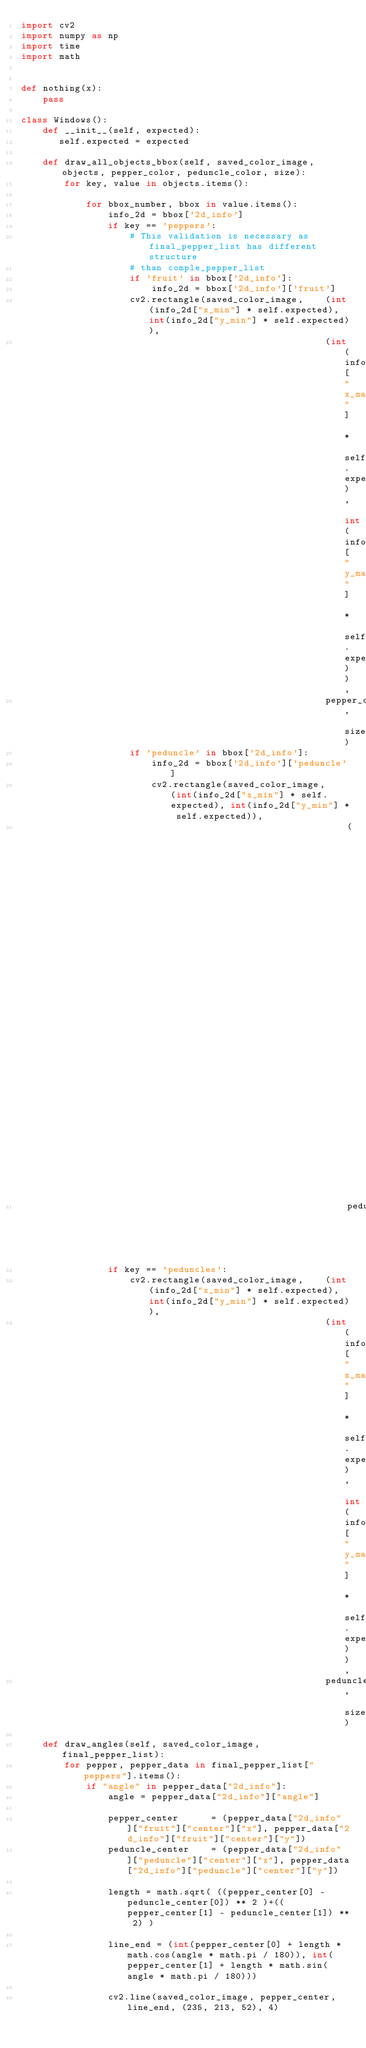<code> <loc_0><loc_0><loc_500><loc_500><_Python_>import cv2
import numpy as np
import time
import math


def nothing(x):
    pass

class Windows():
    def __init__(self, expected):
       self.expected = expected

    def draw_all_objects_bbox(self, saved_color_image, objects, pepper_color, peduncle_color, size):
        for key, value in objects.items():
            
            for bbox_number, bbox in value.items():
                info_2d = bbox['2d_info']
                if key == 'peppers':
                    # This validation is necessary as final_pepper_list has different structure
                    # than comple_pepper_list
                    if 'fruit' in bbox['2d_info']:
                        info_2d = bbox['2d_info']['fruit']
                    cv2.rectangle(saved_color_image,    (int(info_2d["x_min"] * self.expected), int(info_2d["y_min"] * self.expected)), 
                                                        (int(info_2d["x_max"] * self.expected), int(info_2d["y_max"] * self.expected)), 
                                                        pepper_color, size)
                    if 'peduncle' in bbox['2d_info']:
                        info_2d = bbox['2d_info']['peduncle']
                        cv2.rectangle(saved_color_image,    (int(info_2d["x_min"] * self.expected), int(info_2d["y_min"] * self.expected)), 
                                                            (int(info_2d["x_max"] * self.expected), int(info_2d["y_max"] * self.expected)), 
                                                            peduncle_color, size)
                if key == 'peduncles':
                    cv2.rectangle(saved_color_image,    (int(info_2d["x_min"] * self.expected), int(info_2d["y_min"] * self.expected)), 
                                                        (int(info_2d["x_max"] * self.expected), int(info_2d["y_max"] * self.expected)), 
                                                        peduncle_color, size)

    def draw_angles(self, saved_color_image, final_pepper_list):
        for pepper, pepper_data in final_pepper_list["peppers"].items():
            if "angle" in pepper_data["2d_info"]:
                angle = pepper_data["2d_info"]["angle"]
                
                pepper_center      = (pepper_data["2d_info"]["fruit"]["center"]["x"], pepper_data["2d_info"]["fruit"]["center"]["y"])
                peduncle_center    = (pepper_data["2d_info"]["peduncle"]["center"]["x"], pepper_data["2d_info"]["peduncle"]["center"]["y"])
                
                length = math.sqrt( ((pepper_center[0] - peduncle_center[0]) ** 2 )+((pepper_center[1] - peduncle_center[1]) ** 2) )

                line_end = (int(pepper_center[0] + length * math.cos(angle * math.pi / 180)), int(pepper_center[1] + length * math.sin(angle * math.pi / 180)))

                cv2.line(saved_color_image, pepper_center, line_end, (235, 213, 52), 4)
    </code> 